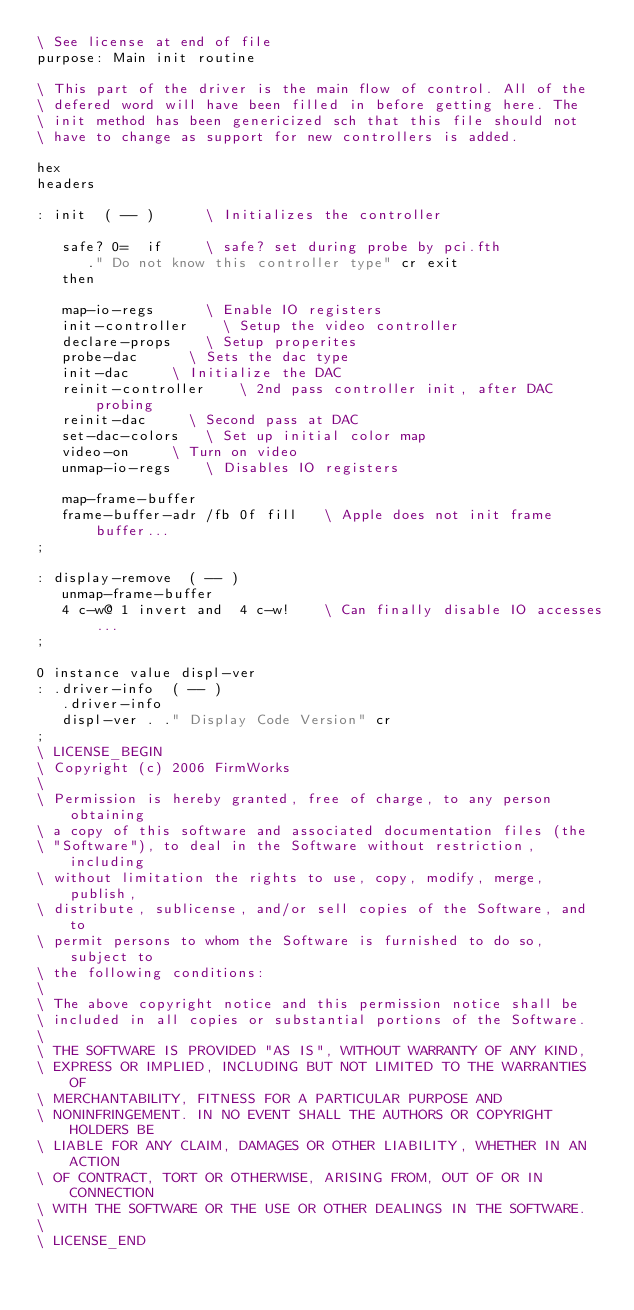Convert code to text. <code><loc_0><loc_0><loc_500><loc_500><_Forth_>\ See license at end of file
purpose: Main init routine

\ This part of the driver is the main flow of control. All of the
\ defered word will have been filled in before getting here. The
\ init method has been genericized sch that this file should not
\ have to change as support for new controllers is added.

hex 
headers

: init  ( -- )			\ Initializes the controller

   safe? 0=  if			\ safe? set during probe by pci.fth
      ." Do not know this controller type" cr exit
   then

   map-io-regs			\ Enable IO registers
   init-controller		\ Setup the video controller
   declare-props		\ Setup properites
   probe-dac			\ Sets the dac type
   init-dac			\ Initialize the DAC
   reinit-controller		\ 2nd pass controller init, after DAC probing
   reinit-dac			\ Second pass at DAC
   set-dac-colors		\ Set up initial color map
   video-on			\ Turn on video
   unmap-io-regs		\ Disables IO registers

   map-frame-buffer
   frame-buffer-adr /fb 0f fill		\ Apple does not init frame buffer...
;

: display-remove  ( -- )
   unmap-frame-buffer 
   4 c-w@ 1 invert and  4 c-w!		\ Can finally disable IO accesses...
;

0 instance value displ-ver
: .driver-info  ( -- )
   .driver-info
   displ-ver . ." Display Code Version" cr
;
\ LICENSE_BEGIN
\ Copyright (c) 2006 FirmWorks
\ 
\ Permission is hereby granted, free of charge, to any person obtaining
\ a copy of this software and associated documentation files (the
\ "Software"), to deal in the Software without restriction, including
\ without limitation the rights to use, copy, modify, merge, publish,
\ distribute, sublicense, and/or sell copies of the Software, and to
\ permit persons to whom the Software is furnished to do so, subject to
\ the following conditions:
\ 
\ The above copyright notice and this permission notice shall be
\ included in all copies or substantial portions of the Software.
\ 
\ THE SOFTWARE IS PROVIDED "AS IS", WITHOUT WARRANTY OF ANY KIND,
\ EXPRESS OR IMPLIED, INCLUDING BUT NOT LIMITED TO THE WARRANTIES OF
\ MERCHANTABILITY, FITNESS FOR A PARTICULAR PURPOSE AND
\ NONINFRINGEMENT. IN NO EVENT SHALL THE AUTHORS OR COPYRIGHT HOLDERS BE
\ LIABLE FOR ANY CLAIM, DAMAGES OR OTHER LIABILITY, WHETHER IN AN ACTION
\ OF CONTRACT, TORT OR OTHERWISE, ARISING FROM, OUT OF OR IN CONNECTION
\ WITH THE SOFTWARE OR THE USE OR OTHER DEALINGS IN THE SOFTWARE.
\
\ LICENSE_END
</code> 